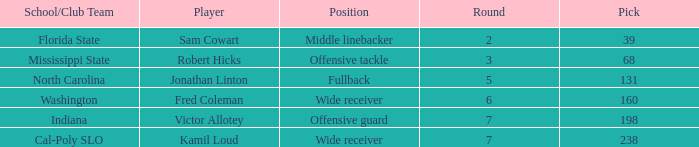Which Round has a School/Club Team of indiana, and a Pick smaller than 198? None. 